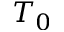<formula> <loc_0><loc_0><loc_500><loc_500>T _ { 0 }</formula> 